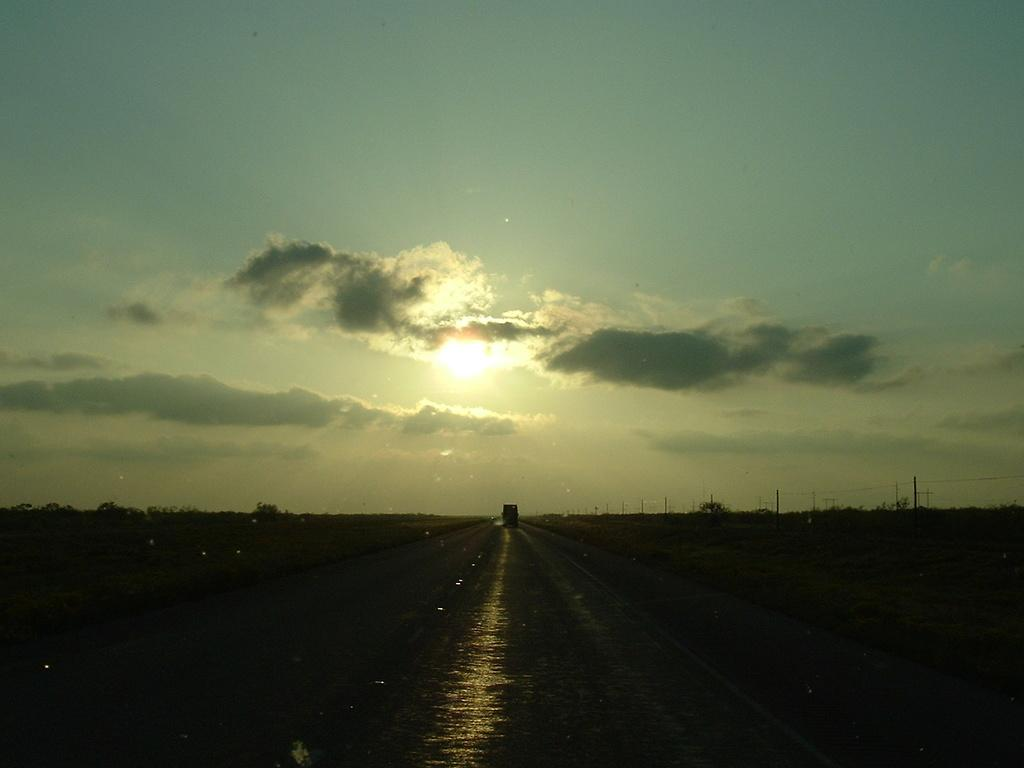What is on the road in the image? There is a vehicle on the road in the image. What type of natural scenery can be seen in the image? There are trees visible in the image. What celestial body is visible in the sky? The sun is observable in the sky. What type of pies are being distributed by the vehicle in the image? There is no indication of pies or distribution in the image; it only shows a vehicle on the road and trees in the background. 